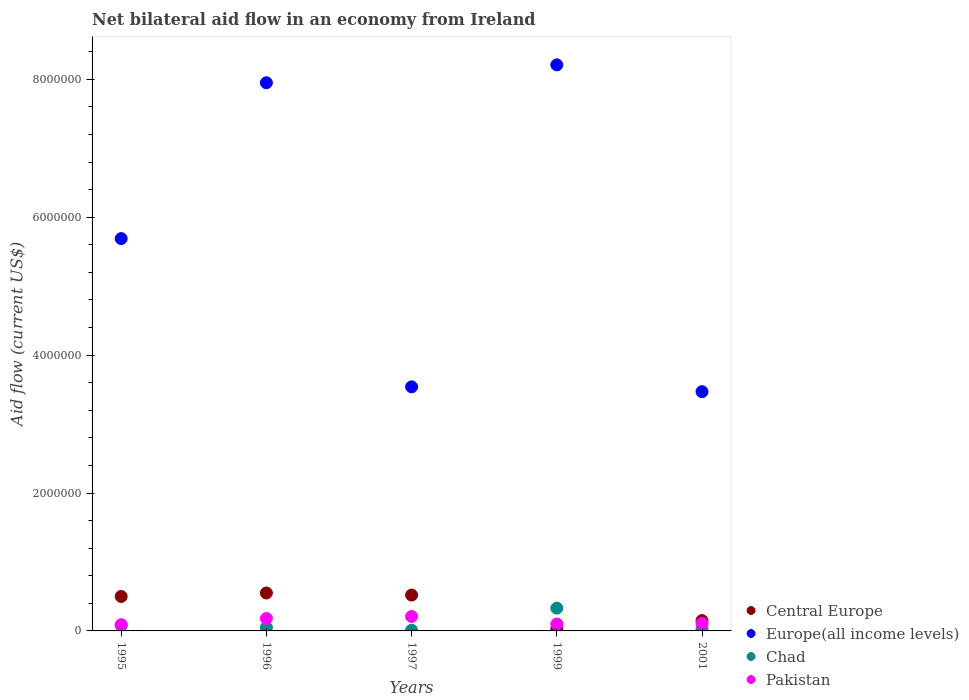What is the net bilateral aid flow in Central Europe in 1997?
Offer a terse response. 5.20e+05. Across all years, what is the maximum net bilateral aid flow in Pakistan?
Your response must be concise. 2.10e+05. In which year was the net bilateral aid flow in Central Europe maximum?
Offer a very short reply. 1996. What is the difference between the net bilateral aid flow in Pakistan in 1997 and that in 2001?
Your response must be concise. 1.00e+05. What is the difference between the net bilateral aid flow in Pakistan in 1997 and the net bilateral aid flow in Europe(all income levels) in 1999?
Provide a short and direct response. -8.00e+06. What is the average net bilateral aid flow in Europe(all income levels) per year?
Ensure brevity in your answer.  5.77e+06. In how many years, is the net bilateral aid flow in Central Europe greater than 800000 US$?
Ensure brevity in your answer.  0. What is the ratio of the net bilateral aid flow in Central Europe in 1997 to that in 2001?
Your answer should be very brief. 3.47. Is the net bilateral aid flow in Central Europe in 1996 less than that in 1999?
Offer a very short reply. No. What is the difference between the highest and the lowest net bilateral aid flow in Chad?
Offer a terse response. 3.20e+05. Is it the case that in every year, the sum of the net bilateral aid flow in Central Europe and net bilateral aid flow in Pakistan  is greater than the sum of net bilateral aid flow in Chad and net bilateral aid flow in Europe(all income levels)?
Provide a succinct answer. No. Does the net bilateral aid flow in Europe(all income levels) monotonically increase over the years?
Provide a short and direct response. No. Is the net bilateral aid flow in Pakistan strictly greater than the net bilateral aid flow in Central Europe over the years?
Offer a very short reply. No. How many dotlines are there?
Your answer should be very brief. 4. How many years are there in the graph?
Keep it short and to the point. 5. Are the values on the major ticks of Y-axis written in scientific E-notation?
Your response must be concise. No. Where does the legend appear in the graph?
Your answer should be compact. Bottom right. What is the title of the graph?
Offer a terse response. Net bilateral aid flow in an economy from Ireland. What is the Aid flow (current US$) of Central Europe in 1995?
Keep it short and to the point. 5.00e+05. What is the Aid flow (current US$) of Europe(all income levels) in 1995?
Your answer should be compact. 5.69e+06. What is the Aid flow (current US$) in Europe(all income levels) in 1996?
Your answer should be compact. 7.95e+06. What is the Aid flow (current US$) in Chad in 1996?
Provide a succinct answer. 5.00e+04. What is the Aid flow (current US$) in Central Europe in 1997?
Provide a succinct answer. 5.20e+05. What is the Aid flow (current US$) of Europe(all income levels) in 1997?
Provide a succinct answer. 3.54e+06. What is the Aid flow (current US$) of Chad in 1997?
Provide a short and direct response. 10000. What is the Aid flow (current US$) of Pakistan in 1997?
Ensure brevity in your answer.  2.10e+05. What is the Aid flow (current US$) in Europe(all income levels) in 1999?
Provide a short and direct response. 8.21e+06. What is the Aid flow (current US$) of Pakistan in 1999?
Ensure brevity in your answer.  1.00e+05. What is the Aid flow (current US$) in Europe(all income levels) in 2001?
Offer a very short reply. 3.47e+06. What is the Aid flow (current US$) of Chad in 2001?
Ensure brevity in your answer.  3.00e+04. Across all years, what is the maximum Aid flow (current US$) in Central Europe?
Your response must be concise. 5.50e+05. Across all years, what is the maximum Aid flow (current US$) of Europe(all income levels)?
Provide a short and direct response. 8.21e+06. Across all years, what is the maximum Aid flow (current US$) in Chad?
Offer a very short reply. 3.30e+05. Across all years, what is the minimum Aid flow (current US$) in Europe(all income levels)?
Offer a very short reply. 3.47e+06. Across all years, what is the minimum Aid flow (current US$) in Pakistan?
Provide a succinct answer. 9.00e+04. What is the total Aid flow (current US$) in Central Europe in the graph?
Offer a terse response. 1.75e+06. What is the total Aid flow (current US$) of Europe(all income levels) in the graph?
Your answer should be very brief. 2.89e+07. What is the total Aid flow (current US$) in Chad in the graph?
Your answer should be very brief. 5.00e+05. What is the total Aid flow (current US$) in Pakistan in the graph?
Your answer should be very brief. 6.90e+05. What is the difference between the Aid flow (current US$) in Central Europe in 1995 and that in 1996?
Your response must be concise. -5.00e+04. What is the difference between the Aid flow (current US$) of Europe(all income levels) in 1995 and that in 1996?
Give a very brief answer. -2.26e+06. What is the difference between the Aid flow (current US$) in Pakistan in 1995 and that in 1996?
Offer a very short reply. -9.00e+04. What is the difference between the Aid flow (current US$) of Europe(all income levels) in 1995 and that in 1997?
Provide a succinct answer. 2.15e+06. What is the difference between the Aid flow (current US$) of Chad in 1995 and that in 1997?
Your answer should be compact. 7.00e+04. What is the difference between the Aid flow (current US$) in Pakistan in 1995 and that in 1997?
Ensure brevity in your answer.  -1.20e+05. What is the difference between the Aid flow (current US$) in Central Europe in 1995 and that in 1999?
Your response must be concise. 4.70e+05. What is the difference between the Aid flow (current US$) of Europe(all income levels) in 1995 and that in 1999?
Your answer should be compact. -2.52e+06. What is the difference between the Aid flow (current US$) in Chad in 1995 and that in 1999?
Give a very brief answer. -2.50e+05. What is the difference between the Aid flow (current US$) of Pakistan in 1995 and that in 1999?
Provide a succinct answer. -10000. What is the difference between the Aid flow (current US$) in Europe(all income levels) in 1995 and that in 2001?
Your answer should be very brief. 2.22e+06. What is the difference between the Aid flow (current US$) in Chad in 1995 and that in 2001?
Keep it short and to the point. 5.00e+04. What is the difference between the Aid flow (current US$) of Pakistan in 1995 and that in 2001?
Your answer should be very brief. -2.00e+04. What is the difference between the Aid flow (current US$) in Central Europe in 1996 and that in 1997?
Keep it short and to the point. 3.00e+04. What is the difference between the Aid flow (current US$) in Europe(all income levels) in 1996 and that in 1997?
Your answer should be very brief. 4.41e+06. What is the difference between the Aid flow (current US$) of Chad in 1996 and that in 1997?
Give a very brief answer. 4.00e+04. What is the difference between the Aid flow (current US$) in Pakistan in 1996 and that in 1997?
Offer a very short reply. -3.00e+04. What is the difference between the Aid flow (current US$) of Central Europe in 1996 and that in 1999?
Make the answer very short. 5.20e+05. What is the difference between the Aid flow (current US$) of Chad in 1996 and that in 1999?
Ensure brevity in your answer.  -2.80e+05. What is the difference between the Aid flow (current US$) in Europe(all income levels) in 1996 and that in 2001?
Provide a succinct answer. 4.48e+06. What is the difference between the Aid flow (current US$) of Europe(all income levels) in 1997 and that in 1999?
Offer a terse response. -4.67e+06. What is the difference between the Aid flow (current US$) of Chad in 1997 and that in 1999?
Give a very brief answer. -3.20e+05. What is the difference between the Aid flow (current US$) of Pakistan in 1997 and that in 1999?
Your response must be concise. 1.10e+05. What is the difference between the Aid flow (current US$) in Central Europe in 1997 and that in 2001?
Provide a succinct answer. 3.70e+05. What is the difference between the Aid flow (current US$) in Chad in 1997 and that in 2001?
Provide a short and direct response. -2.00e+04. What is the difference between the Aid flow (current US$) in Pakistan in 1997 and that in 2001?
Keep it short and to the point. 1.00e+05. What is the difference between the Aid flow (current US$) of Central Europe in 1999 and that in 2001?
Offer a very short reply. -1.20e+05. What is the difference between the Aid flow (current US$) of Europe(all income levels) in 1999 and that in 2001?
Keep it short and to the point. 4.74e+06. What is the difference between the Aid flow (current US$) of Chad in 1999 and that in 2001?
Keep it short and to the point. 3.00e+05. What is the difference between the Aid flow (current US$) in Central Europe in 1995 and the Aid flow (current US$) in Europe(all income levels) in 1996?
Your response must be concise. -7.45e+06. What is the difference between the Aid flow (current US$) of Central Europe in 1995 and the Aid flow (current US$) of Chad in 1996?
Give a very brief answer. 4.50e+05. What is the difference between the Aid flow (current US$) in Europe(all income levels) in 1995 and the Aid flow (current US$) in Chad in 1996?
Your answer should be very brief. 5.64e+06. What is the difference between the Aid flow (current US$) in Europe(all income levels) in 1995 and the Aid flow (current US$) in Pakistan in 1996?
Give a very brief answer. 5.51e+06. What is the difference between the Aid flow (current US$) of Central Europe in 1995 and the Aid flow (current US$) of Europe(all income levels) in 1997?
Your answer should be very brief. -3.04e+06. What is the difference between the Aid flow (current US$) in Central Europe in 1995 and the Aid flow (current US$) in Chad in 1997?
Your answer should be compact. 4.90e+05. What is the difference between the Aid flow (current US$) in Central Europe in 1995 and the Aid flow (current US$) in Pakistan in 1997?
Keep it short and to the point. 2.90e+05. What is the difference between the Aid flow (current US$) of Europe(all income levels) in 1995 and the Aid flow (current US$) of Chad in 1997?
Your answer should be very brief. 5.68e+06. What is the difference between the Aid flow (current US$) of Europe(all income levels) in 1995 and the Aid flow (current US$) of Pakistan in 1997?
Provide a short and direct response. 5.48e+06. What is the difference between the Aid flow (current US$) of Chad in 1995 and the Aid flow (current US$) of Pakistan in 1997?
Your answer should be compact. -1.30e+05. What is the difference between the Aid flow (current US$) of Central Europe in 1995 and the Aid flow (current US$) of Europe(all income levels) in 1999?
Your response must be concise. -7.71e+06. What is the difference between the Aid flow (current US$) in Central Europe in 1995 and the Aid flow (current US$) in Chad in 1999?
Provide a succinct answer. 1.70e+05. What is the difference between the Aid flow (current US$) of Europe(all income levels) in 1995 and the Aid flow (current US$) of Chad in 1999?
Keep it short and to the point. 5.36e+06. What is the difference between the Aid flow (current US$) in Europe(all income levels) in 1995 and the Aid flow (current US$) in Pakistan in 1999?
Your answer should be compact. 5.59e+06. What is the difference between the Aid flow (current US$) in Central Europe in 1995 and the Aid flow (current US$) in Europe(all income levels) in 2001?
Your response must be concise. -2.97e+06. What is the difference between the Aid flow (current US$) in Central Europe in 1995 and the Aid flow (current US$) in Chad in 2001?
Your response must be concise. 4.70e+05. What is the difference between the Aid flow (current US$) in Europe(all income levels) in 1995 and the Aid flow (current US$) in Chad in 2001?
Keep it short and to the point. 5.66e+06. What is the difference between the Aid flow (current US$) in Europe(all income levels) in 1995 and the Aid flow (current US$) in Pakistan in 2001?
Make the answer very short. 5.58e+06. What is the difference between the Aid flow (current US$) in Central Europe in 1996 and the Aid flow (current US$) in Europe(all income levels) in 1997?
Your answer should be compact. -2.99e+06. What is the difference between the Aid flow (current US$) of Central Europe in 1996 and the Aid flow (current US$) of Chad in 1997?
Provide a succinct answer. 5.40e+05. What is the difference between the Aid flow (current US$) in Central Europe in 1996 and the Aid flow (current US$) in Pakistan in 1997?
Offer a very short reply. 3.40e+05. What is the difference between the Aid flow (current US$) in Europe(all income levels) in 1996 and the Aid flow (current US$) in Chad in 1997?
Keep it short and to the point. 7.94e+06. What is the difference between the Aid flow (current US$) in Europe(all income levels) in 1996 and the Aid flow (current US$) in Pakistan in 1997?
Offer a terse response. 7.74e+06. What is the difference between the Aid flow (current US$) in Central Europe in 1996 and the Aid flow (current US$) in Europe(all income levels) in 1999?
Offer a very short reply. -7.66e+06. What is the difference between the Aid flow (current US$) of Europe(all income levels) in 1996 and the Aid flow (current US$) of Chad in 1999?
Ensure brevity in your answer.  7.62e+06. What is the difference between the Aid flow (current US$) in Europe(all income levels) in 1996 and the Aid flow (current US$) in Pakistan in 1999?
Make the answer very short. 7.85e+06. What is the difference between the Aid flow (current US$) of Chad in 1996 and the Aid flow (current US$) of Pakistan in 1999?
Offer a very short reply. -5.00e+04. What is the difference between the Aid flow (current US$) of Central Europe in 1996 and the Aid flow (current US$) of Europe(all income levels) in 2001?
Provide a short and direct response. -2.92e+06. What is the difference between the Aid flow (current US$) of Central Europe in 1996 and the Aid flow (current US$) of Chad in 2001?
Your answer should be compact. 5.20e+05. What is the difference between the Aid flow (current US$) of Europe(all income levels) in 1996 and the Aid flow (current US$) of Chad in 2001?
Your answer should be very brief. 7.92e+06. What is the difference between the Aid flow (current US$) of Europe(all income levels) in 1996 and the Aid flow (current US$) of Pakistan in 2001?
Give a very brief answer. 7.84e+06. What is the difference between the Aid flow (current US$) of Central Europe in 1997 and the Aid flow (current US$) of Europe(all income levels) in 1999?
Offer a very short reply. -7.69e+06. What is the difference between the Aid flow (current US$) of Central Europe in 1997 and the Aid flow (current US$) of Pakistan in 1999?
Ensure brevity in your answer.  4.20e+05. What is the difference between the Aid flow (current US$) in Europe(all income levels) in 1997 and the Aid flow (current US$) in Chad in 1999?
Your answer should be very brief. 3.21e+06. What is the difference between the Aid flow (current US$) of Europe(all income levels) in 1997 and the Aid flow (current US$) of Pakistan in 1999?
Provide a short and direct response. 3.44e+06. What is the difference between the Aid flow (current US$) in Chad in 1997 and the Aid flow (current US$) in Pakistan in 1999?
Offer a terse response. -9.00e+04. What is the difference between the Aid flow (current US$) of Central Europe in 1997 and the Aid flow (current US$) of Europe(all income levels) in 2001?
Offer a terse response. -2.95e+06. What is the difference between the Aid flow (current US$) in Europe(all income levels) in 1997 and the Aid flow (current US$) in Chad in 2001?
Offer a terse response. 3.51e+06. What is the difference between the Aid flow (current US$) of Europe(all income levels) in 1997 and the Aid flow (current US$) of Pakistan in 2001?
Your answer should be very brief. 3.43e+06. What is the difference between the Aid flow (current US$) of Central Europe in 1999 and the Aid flow (current US$) of Europe(all income levels) in 2001?
Your answer should be compact. -3.44e+06. What is the difference between the Aid flow (current US$) of Central Europe in 1999 and the Aid flow (current US$) of Pakistan in 2001?
Provide a short and direct response. -8.00e+04. What is the difference between the Aid flow (current US$) of Europe(all income levels) in 1999 and the Aid flow (current US$) of Chad in 2001?
Make the answer very short. 8.18e+06. What is the difference between the Aid flow (current US$) in Europe(all income levels) in 1999 and the Aid flow (current US$) in Pakistan in 2001?
Your answer should be compact. 8.10e+06. What is the average Aid flow (current US$) in Central Europe per year?
Provide a short and direct response. 3.50e+05. What is the average Aid flow (current US$) in Europe(all income levels) per year?
Your response must be concise. 5.77e+06. What is the average Aid flow (current US$) of Chad per year?
Keep it short and to the point. 1.00e+05. What is the average Aid flow (current US$) of Pakistan per year?
Your answer should be compact. 1.38e+05. In the year 1995, what is the difference between the Aid flow (current US$) in Central Europe and Aid flow (current US$) in Europe(all income levels)?
Give a very brief answer. -5.19e+06. In the year 1995, what is the difference between the Aid flow (current US$) in Central Europe and Aid flow (current US$) in Pakistan?
Provide a succinct answer. 4.10e+05. In the year 1995, what is the difference between the Aid flow (current US$) of Europe(all income levels) and Aid flow (current US$) of Chad?
Your response must be concise. 5.61e+06. In the year 1995, what is the difference between the Aid flow (current US$) in Europe(all income levels) and Aid flow (current US$) in Pakistan?
Offer a terse response. 5.60e+06. In the year 1995, what is the difference between the Aid flow (current US$) in Chad and Aid flow (current US$) in Pakistan?
Provide a short and direct response. -10000. In the year 1996, what is the difference between the Aid flow (current US$) in Central Europe and Aid flow (current US$) in Europe(all income levels)?
Your response must be concise. -7.40e+06. In the year 1996, what is the difference between the Aid flow (current US$) in Central Europe and Aid flow (current US$) in Pakistan?
Ensure brevity in your answer.  3.70e+05. In the year 1996, what is the difference between the Aid flow (current US$) in Europe(all income levels) and Aid flow (current US$) in Chad?
Make the answer very short. 7.90e+06. In the year 1996, what is the difference between the Aid flow (current US$) of Europe(all income levels) and Aid flow (current US$) of Pakistan?
Your answer should be compact. 7.77e+06. In the year 1997, what is the difference between the Aid flow (current US$) in Central Europe and Aid flow (current US$) in Europe(all income levels)?
Give a very brief answer. -3.02e+06. In the year 1997, what is the difference between the Aid flow (current US$) of Central Europe and Aid flow (current US$) of Chad?
Provide a short and direct response. 5.10e+05. In the year 1997, what is the difference between the Aid flow (current US$) in Europe(all income levels) and Aid flow (current US$) in Chad?
Give a very brief answer. 3.53e+06. In the year 1997, what is the difference between the Aid flow (current US$) in Europe(all income levels) and Aid flow (current US$) in Pakistan?
Provide a short and direct response. 3.33e+06. In the year 1999, what is the difference between the Aid flow (current US$) of Central Europe and Aid flow (current US$) of Europe(all income levels)?
Provide a succinct answer. -8.18e+06. In the year 1999, what is the difference between the Aid flow (current US$) in Europe(all income levels) and Aid flow (current US$) in Chad?
Offer a very short reply. 7.88e+06. In the year 1999, what is the difference between the Aid flow (current US$) in Europe(all income levels) and Aid flow (current US$) in Pakistan?
Your answer should be very brief. 8.11e+06. In the year 1999, what is the difference between the Aid flow (current US$) in Chad and Aid flow (current US$) in Pakistan?
Your response must be concise. 2.30e+05. In the year 2001, what is the difference between the Aid flow (current US$) in Central Europe and Aid flow (current US$) in Europe(all income levels)?
Make the answer very short. -3.32e+06. In the year 2001, what is the difference between the Aid flow (current US$) in Central Europe and Aid flow (current US$) in Chad?
Ensure brevity in your answer.  1.20e+05. In the year 2001, what is the difference between the Aid flow (current US$) in Europe(all income levels) and Aid flow (current US$) in Chad?
Your answer should be very brief. 3.44e+06. In the year 2001, what is the difference between the Aid flow (current US$) in Europe(all income levels) and Aid flow (current US$) in Pakistan?
Offer a very short reply. 3.36e+06. In the year 2001, what is the difference between the Aid flow (current US$) of Chad and Aid flow (current US$) of Pakistan?
Provide a succinct answer. -8.00e+04. What is the ratio of the Aid flow (current US$) in Central Europe in 1995 to that in 1996?
Make the answer very short. 0.91. What is the ratio of the Aid flow (current US$) of Europe(all income levels) in 1995 to that in 1996?
Make the answer very short. 0.72. What is the ratio of the Aid flow (current US$) of Pakistan in 1995 to that in 1996?
Offer a very short reply. 0.5. What is the ratio of the Aid flow (current US$) in Central Europe in 1995 to that in 1997?
Your response must be concise. 0.96. What is the ratio of the Aid flow (current US$) in Europe(all income levels) in 1995 to that in 1997?
Ensure brevity in your answer.  1.61. What is the ratio of the Aid flow (current US$) of Pakistan in 1995 to that in 1997?
Keep it short and to the point. 0.43. What is the ratio of the Aid flow (current US$) in Central Europe in 1995 to that in 1999?
Make the answer very short. 16.67. What is the ratio of the Aid flow (current US$) of Europe(all income levels) in 1995 to that in 1999?
Your answer should be compact. 0.69. What is the ratio of the Aid flow (current US$) in Chad in 1995 to that in 1999?
Keep it short and to the point. 0.24. What is the ratio of the Aid flow (current US$) of Pakistan in 1995 to that in 1999?
Provide a short and direct response. 0.9. What is the ratio of the Aid flow (current US$) of Central Europe in 1995 to that in 2001?
Your answer should be compact. 3.33. What is the ratio of the Aid flow (current US$) of Europe(all income levels) in 1995 to that in 2001?
Ensure brevity in your answer.  1.64. What is the ratio of the Aid flow (current US$) of Chad in 1995 to that in 2001?
Make the answer very short. 2.67. What is the ratio of the Aid flow (current US$) of Pakistan in 1995 to that in 2001?
Give a very brief answer. 0.82. What is the ratio of the Aid flow (current US$) of Central Europe in 1996 to that in 1997?
Ensure brevity in your answer.  1.06. What is the ratio of the Aid flow (current US$) of Europe(all income levels) in 1996 to that in 1997?
Your answer should be very brief. 2.25. What is the ratio of the Aid flow (current US$) of Central Europe in 1996 to that in 1999?
Your response must be concise. 18.33. What is the ratio of the Aid flow (current US$) of Europe(all income levels) in 1996 to that in 1999?
Keep it short and to the point. 0.97. What is the ratio of the Aid flow (current US$) of Chad in 1996 to that in 1999?
Offer a terse response. 0.15. What is the ratio of the Aid flow (current US$) in Pakistan in 1996 to that in 1999?
Your answer should be compact. 1.8. What is the ratio of the Aid flow (current US$) of Central Europe in 1996 to that in 2001?
Give a very brief answer. 3.67. What is the ratio of the Aid flow (current US$) in Europe(all income levels) in 1996 to that in 2001?
Keep it short and to the point. 2.29. What is the ratio of the Aid flow (current US$) in Chad in 1996 to that in 2001?
Offer a very short reply. 1.67. What is the ratio of the Aid flow (current US$) of Pakistan in 1996 to that in 2001?
Give a very brief answer. 1.64. What is the ratio of the Aid flow (current US$) in Central Europe in 1997 to that in 1999?
Give a very brief answer. 17.33. What is the ratio of the Aid flow (current US$) of Europe(all income levels) in 1997 to that in 1999?
Keep it short and to the point. 0.43. What is the ratio of the Aid flow (current US$) in Chad in 1997 to that in 1999?
Your response must be concise. 0.03. What is the ratio of the Aid flow (current US$) of Pakistan in 1997 to that in 1999?
Provide a succinct answer. 2.1. What is the ratio of the Aid flow (current US$) of Central Europe in 1997 to that in 2001?
Offer a terse response. 3.47. What is the ratio of the Aid flow (current US$) of Europe(all income levels) in 1997 to that in 2001?
Keep it short and to the point. 1.02. What is the ratio of the Aid flow (current US$) of Chad in 1997 to that in 2001?
Ensure brevity in your answer.  0.33. What is the ratio of the Aid flow (current US$) in Pakistan in 1997 to that in 2001?
Make the answer very short. 1.91. What is the ratio of the Aid flow (current US$) in Europe(all income levels) in 1999 to that in 2001?
Provide a short and direct response. 2.37. What is the ratio of the Aid flow (current US$) in Pakistan in 1999 to that in 2001?
Your answer should be very brief. 0.91. What is the difference between the highest and the second highest Aid flow (current US$) of Central Europe?
Offer a very short reply. 3.00e+04. What is the difference between the highest and the second highest Aid flow (current US$) of Europe(all income levels)?
Your answer should be compact. 2.60e+05. What is the difference between the highest and the second highest Aid flow (current US$) in Chad?
Give a very brief answer. 2.50e+05. What is the difference between the highest and the second highest Aid flow (current US$) in Pakistan?
Provide a short and direct response. 3.00e+04. What is the difference between the highest and the lowest Aid flow (current US$) in Central Europe?
Keep it short and to the point. 5.20e+05. What is the difference between the highest and the lowest Aid flow (current US$) of Europe(all income levels)?
Keep it short and to the point. 4.74e+06. What is the difference between the highest and the lowest Aid flow (current US$) in Chad?
Provide a succinct answer. 3.20e+05. 